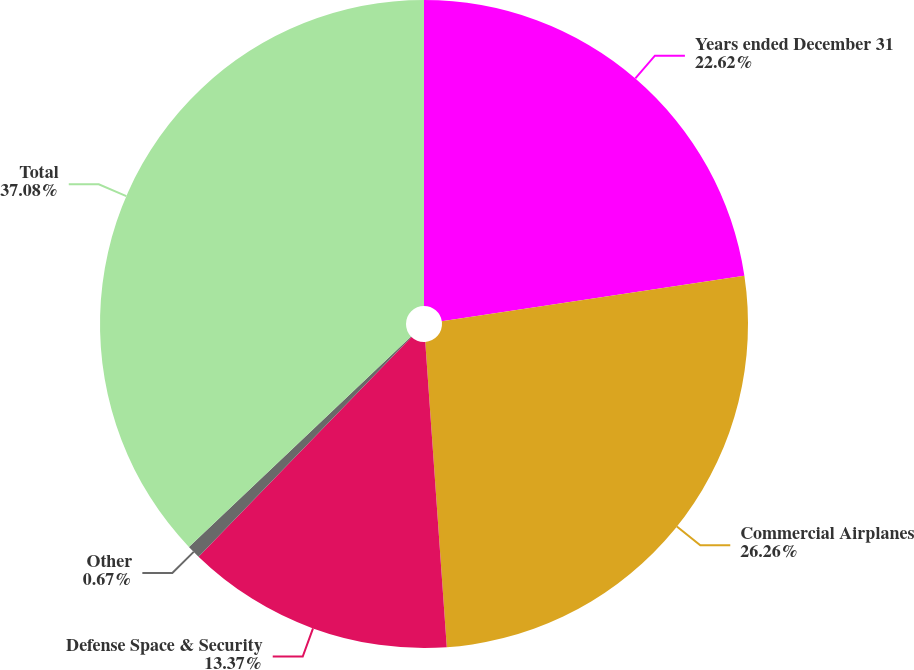Convert chart to OTSL. <chart><loc_0><loc_0><loc_500><loc_500><pie_chart><fcel>Years ended December 31<fcel>Commercial Airplanes<fcel>Defense Space & Security<fcel>Other<fcel>Total<nl><fcel>22.62%<fcel>26.26%<fcel>13.37%<fcel>0.67%<fcel>37.08%<nl></chart> 